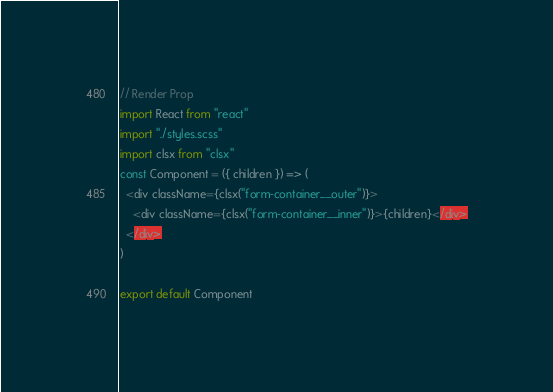<code> <loc_0><loc_0><loc_500><loc_500><_JavaScript_>// Render Prop
import React from "react"
import "./styles.scss"
import clsx from "clsx"
const Component = ({ children }) => (
  <div className={clsx("form-container__outer")}>
    <div className={clsx("form-container__inner")}>{children}</div>
  </div>
)

export default Component
</code> 